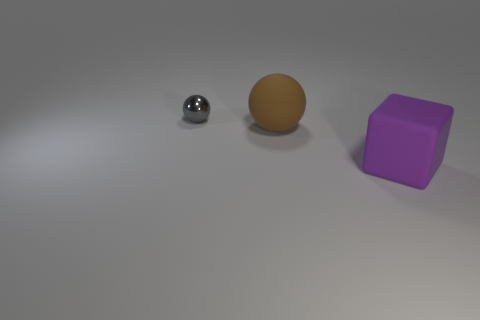What materials seem to be represented in the objects depicted in the image? The image showcases objects that appear to have different materials. There's a sphere with a reflective, metallic surface, likely meant to represent metal or chrome. The large ball has a matte finish resembling rubber, and the cube exhibits a solid color and texture, also similar to rubber. 